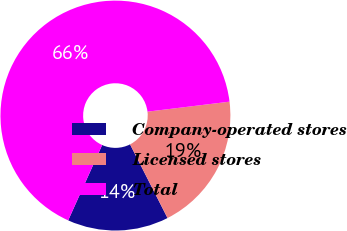Convert chart. <chart><loc_0><loc_0><loc_500><loc_500><pie_chart><fcel>Company-operated stores<fcel>Licensed stores<fcel>Total<nl><fcel>14.23%<fcel>19.44%<fcel>66.33%<nl></chart> 